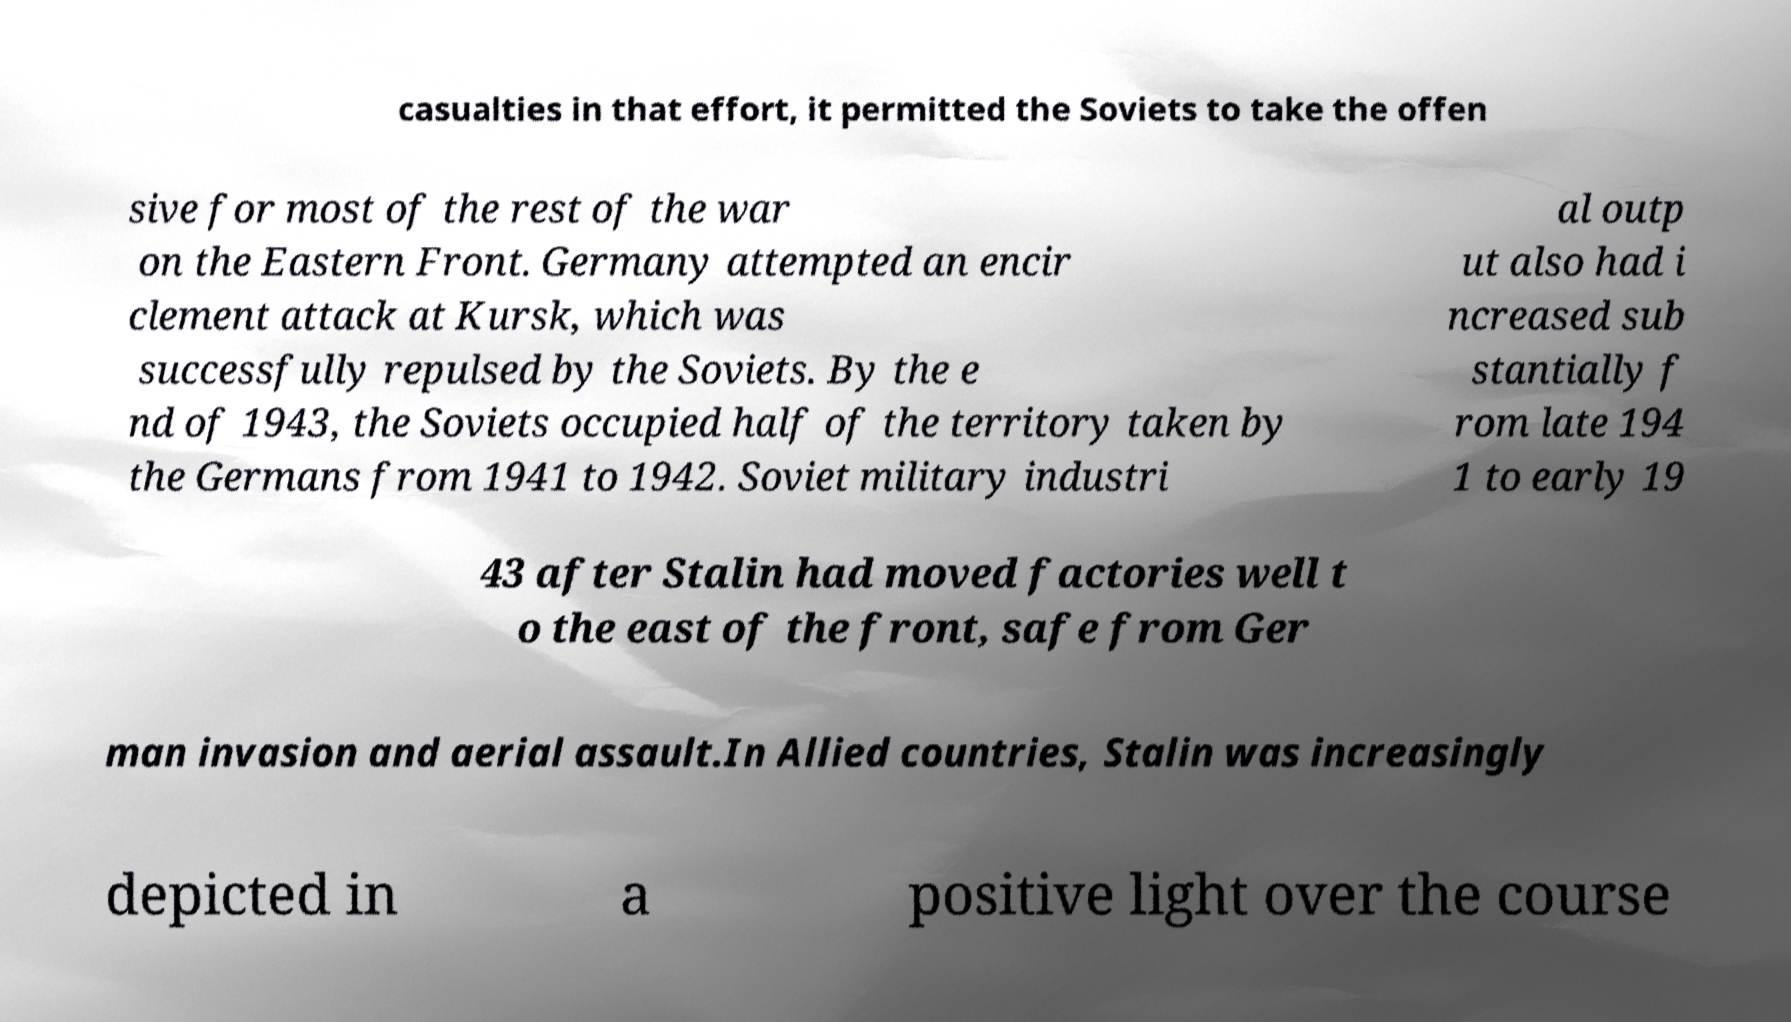Can you accurately transcribe the text from the provided image for me? casualties in that effort, it permitted the Soviets to take the offen sive for most of the rest of the war on the Eastern Front. Germany attempted an encir clement attack at Kursk, which was successfully repulsed by the Soviets. By the e nd of 1943, the Soviets occupied half of the territory taken by the Germans from 1941 to 1942. Soviet military industri al outp ut also had i ncreased sub stantially f rom late 194 1 to early 19 43 after Stalin had moved factories well t o the east of the front, safe from Ger man invasion and aerial assault.In Allied countries, Stalin was increasingly depicted in a positive light over the course 